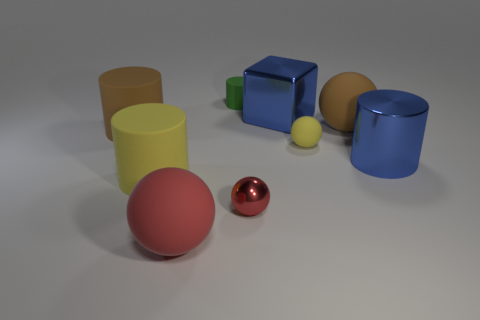What number of tiny red metal objects are the same shape as the tiny yellow matte object?
Your answer should be very brief. 1. Is there a big rubber cylinder that has the same color as the metal ball?
Ensure brevity in your answer.  No. What number of things are cylinders in front of the yellow rubber ball or large brown rubber objects that are left of the large yellow matte cylinder?
Offer a terse response. 3. Is there a large blue metallic thing to the left of the yellow matte thing that is behind the big blue shiny cylinder?
Make the answer very short. Yes. What shape is the red matte thing that is the same size as the brown matte ball?
Your response must be concise. Sphere. What number of objects are either small rubber objects on the right side of the large red object or large metallic blocks?
Provide a short and direct response. 3. What number of other things are there of the same material as the cube
Your response must be concise. 2. The large thing that is the same color as the small metallic ball is what shape?
Your answer should be compact. Sphere. How big is the brown object that is left of the small cylinder?
Offer a very short reply. Large. There is a small object that is made of the same material as the small cylinder; what shape is it?
Ensure brevity in your answer.  Sphere. 